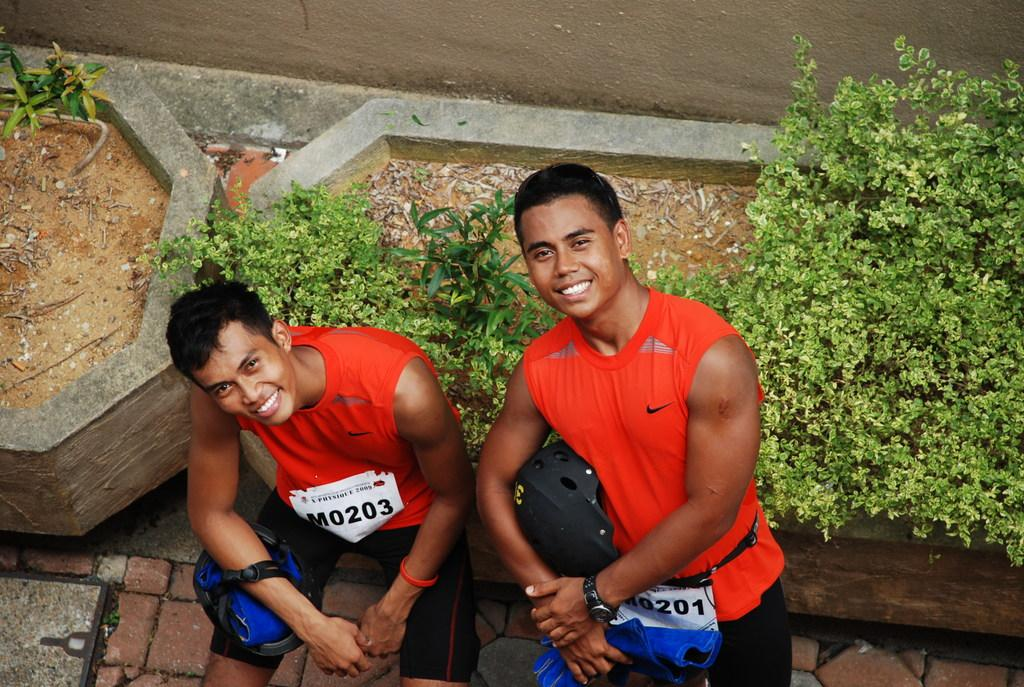How many people are in the image? There are two people in the image. What are the people doing in the image? The people are standing and smiling. What colors are the dresses worn by the people in the image? One person is wearing a red dress, and the other person is wearing a black dress. What can be seen in the background of the image? There are trees visible in the background of the image. What type of furniture can be seen in the image? There is no furniture present in the image. What rhythm is the bubble following in the image? There is no bubble present in the image, and therefore no rhythm can be observed. 